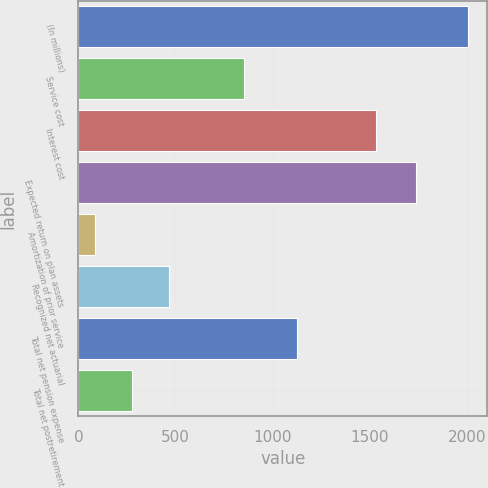Convert chart to OTSL. <chart><loc_0><loc_0><loc_500><loc_500><bar_chart><fcel>(In millions)<fcel>Service cost<fcel>Interest cost<fcel>Expected return on plan assets<fcel>Amortization of prior service<fcel>Recognized net actuarial<fcel>Total net pension expense<fcel>Total net postretirement<nl><fcel>2005<fcel>852<fcel>1535<fcel>1740<fcel>85<fcel>469<fcel>1124<fcel>277<nl></chart> 